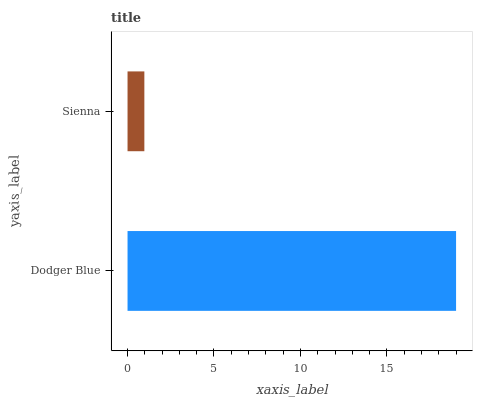Is Sienna the minimum?
Answer yes or no. Yes. Is Dodger Blue the maximum?
Answer yes or no. Yes. Is Sienna the maximum?
Answer yes or no. No. Is Dodger Blue greater than Sienna?
Answer yes or no. Yes. Is Sienna less than Dodger Blue?
Answer yes or no. Yes. Is Sienna greater than Dodger Blue?
Answer yes or no. No. Is Dodger Blue less than Sienna?
Answer yes or no. No. Is Dodger Blue the high median?
Answer yes or no. Yes. Is Sienna the low median?
Answer yes or no. Yes. Is Sienna the high median?
Answer yes or no. No. Is Dodger Blue the low median?
Answer yes or no. No. 